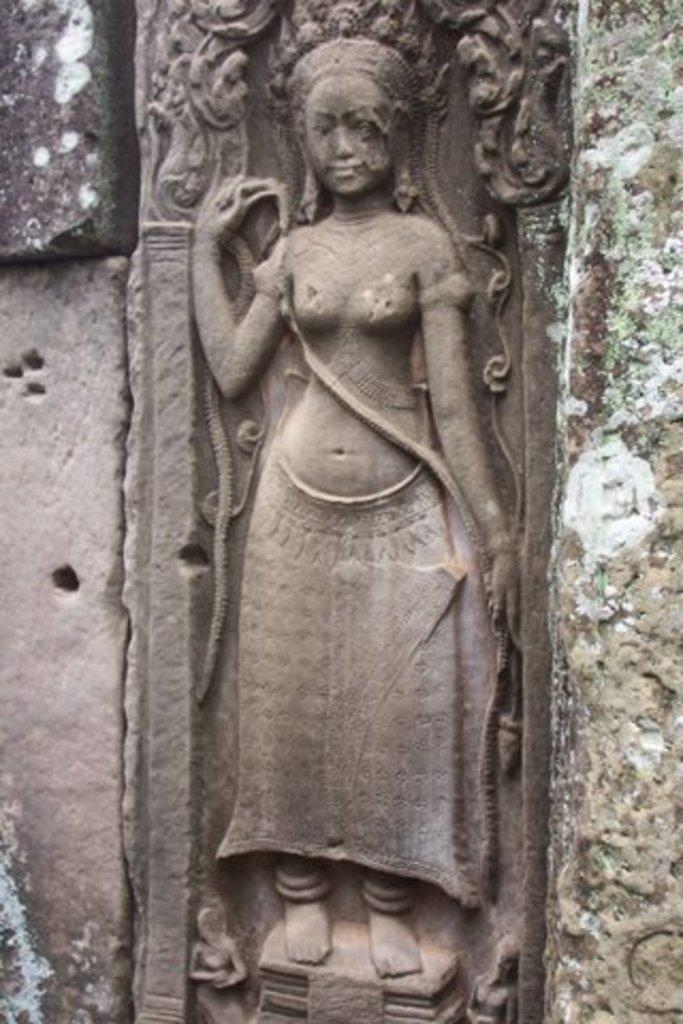What is the main subject of the picture? The main subject of the picture is a sculpture. Can you describe the sculpture in the picture? The sculpture is of a woman. Where is the sculpture located in the picture? The sculpture is on the wall. What type of station can be seen in the background of the image? There is no station visible in the image; it features a sculpture of a woman on the wall. Is there a building with a water fountain in the image? There is no building or water fountain present in the image. 